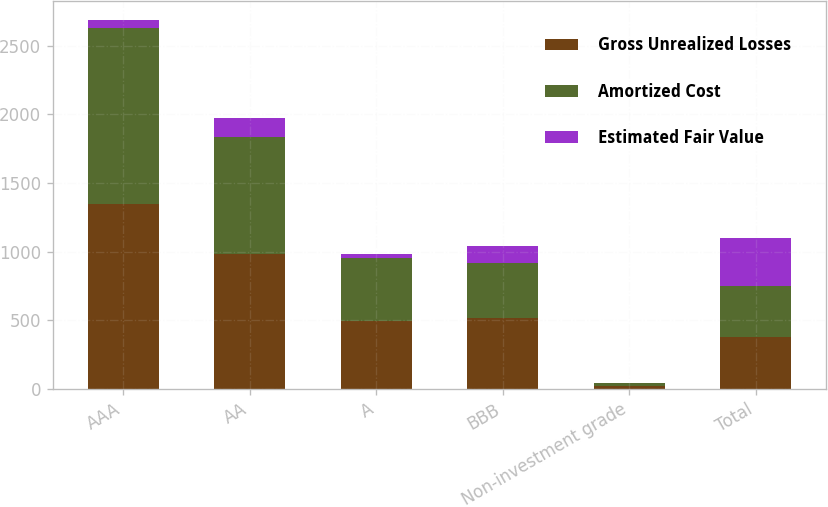Convert chart to OTSL. <chart><loc_0><loc_0><loc_500><loc_500><stacked_bar_chart><ecel><fcel>AAA<fcel>AA<fcel>A<fcel>BBB<fcel>Non-investment grade<fcel>Total<nl><fcel>Gross Unrealized Losses<fcel>1344<fcel>985<fcel>492<fcel>519<fcel>22<fcel>374.5<nl><fcel>Amortized Cost<fcel>1280<fcel>849<fcel>464<fcel>399<fcel>20<fcel>374.5<nl><fcel>Estimated Fair Value<fcel>64<fcel>136<fcel>28<fcel>120<fcel>2<fcel>350<nl></chart> 